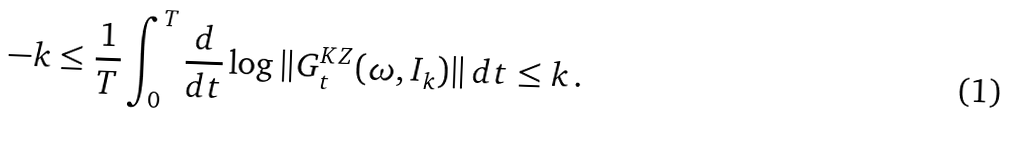Convert formula to latex. <formula><loc_0><loc_0><loc_500><loc_500>- k \leq \frac { 1 } { T } \int _ { 0 } ^ { T } \frac { d } { d t } \log \| G ^ { K Z } _ { t } ( \omega , I _ { k } ) \| \, d t \leq k \, .</formula> 